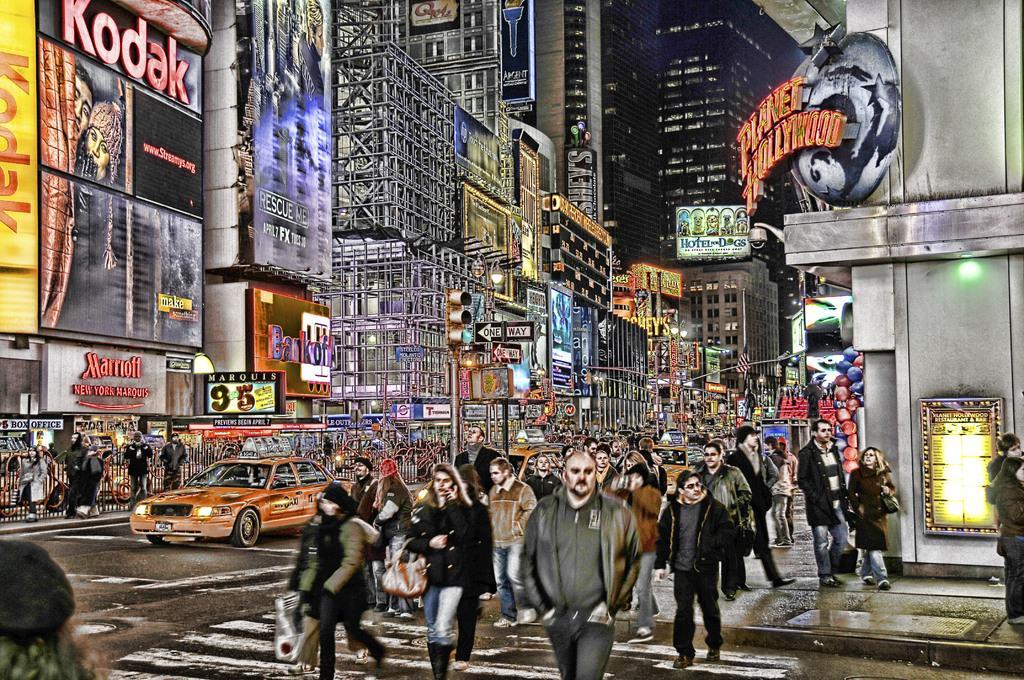Could you give a brief overview of what you see in this image? In this image I can see a painting of buildings, vehicles on the road and people. I can also see some boards attached to the buildings and traffic lights. 